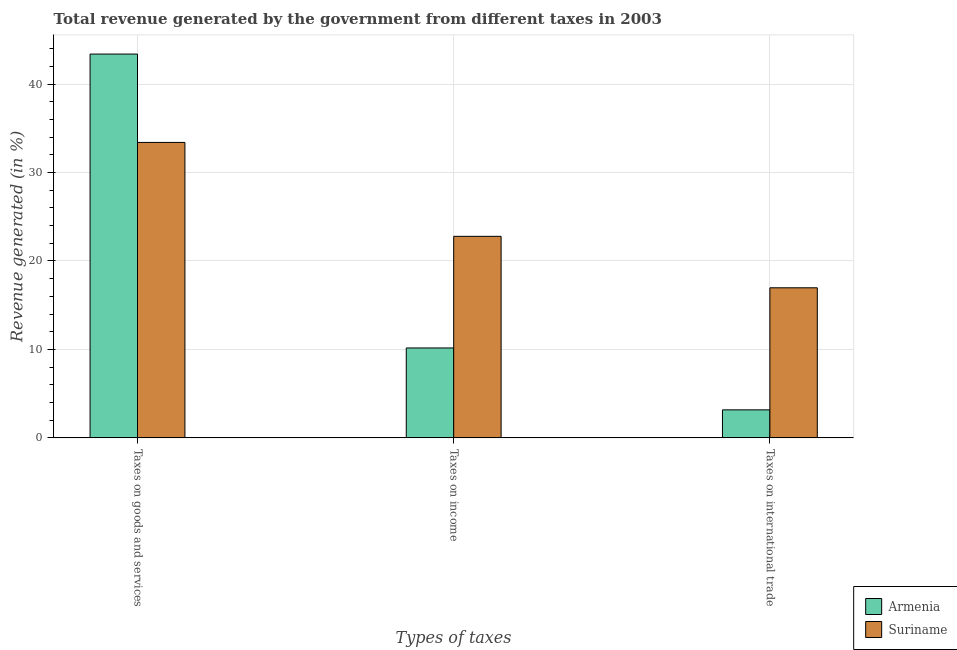How many different coloured bars are there?
Ensure brevity in your answer.  2. How many groups of bars are there?
Give a very brief answer. 3. Are the number of bars per tick equal to the number of legend labels?
Your answer should be very brief. Yes. What is the label of the 2nd group of bars from the left?
Your response must be concise. Taxes on income. What is the percentage of revenue generated by taxes on goods and services in Suriname?
Keep it short and to the point. 33.4. Across all countries, what is the maximum percentage of revenue generated by taxes on goods and services?
Provide a short and direct response. 43.39. Across all countries, what is the minimum percentage of revenue generated by taxes on goods and services?
Your answer should be very brief. 33.4. In which country was the percentage of revenue generated by taxes on goods and services maximum?
Give a very brief answer. Armenia. In which country was the percentage of revenue generated by tax on international trade minimum?
Provide a succinct answer. Armenia. What is the total percentage of revenue generated by tax on international trade in the graph?
Offer a very short reply. 20.14. What is the difference between the percentage of revenue generated by tax on international trade in Suriname and that in Armenia?
Keep it short and to the point. 13.8. What is the difference between the percentage of revenue generated by tax on international trade in Armenia and the percentage of revenue generated by taxes on goods and services in Suriname?
Give a very brief answer. -30.24. What is the average percentage of revenue generated by tax on international trade per country?
Ensure brevity in your answer.  10.07. What is the difference between the percentage of revenue generated by tax on international trade and percentage of revenue generated by taxes on income in Suriname?
Ensure brevity in your answer.  -5.82. In how many countries, is the percentage of revenue generated by taxes on income greater than 6 %?
Offer a very short reply. 2. What is the ratio of the percentage of revenue generated by taxes on income in Armenia to that in Suriname?
Your answer should be compact. 0.45. Is the difference between the percentage of revenue generated by taxes on goods and services in Suriname and Armenia greater than the difference between the percentage of revenue generated by taxes on income in Suriname and Armenia?
Your answer should be very brief. No. What is the difference between the highest and the second highest percentage of revenue generated by taxes on income?
Your answer should be very brief. 12.62. What is the difference between the highest and the lowest percentage of revenue generated by taxes on income?
Offer a terse response. 12.62. In how many countries, is the percentage of revenue generated by taxes on goods and services greater than the average percentage of revenue generated by taxes on goods and services taken over all countries?
Provide a short and direct response. 1. Is the sum of the percentage of revenue generated by tax on international trade in Armenia and Suriname greater than the maximum percentage of revenue generated by taxes on income across all countries?
Provide a short and direct response. No. What does the 1st bar from the left in Taxes on income represents?
Your answer should be compact. Armenia. What does the 1st bar from the right in Taxes on income represents?
Your response must be concise. Suriname. Is it the case that in every country, the sum of the percentage of revenue generated by taxes on goods and services and percentage of revenue generated by taxes on income is greater than the percentage of revenue generated by tax on international trade?
Keep it short and to the point. Yes. How many bars are there?
Give a very brief answer. 6. Are all the bars in the graph horizontal?
Offer a terse response. No. Where does the legend appear in the graph?
Make the answer very short. Bottom right. How many legend labels are there?
Your answer should be compact. 2. How are the legend labels stacked?
Provide a succinct answer. Vertical. What is the title of the graph?
Give a very brief answer. Total revenue generated by the government from different taxes in 2003. Does "Mexico" appear as one of the legend labels in the graph?
Your answer should be compact. No. What is the label or title of the X-axis?
Your answer should be compact. Types of taxes. What is the label or title of the Y-axis?
Make the answer very short. Revenue generated (in %). What is the Revenue generated (in %) in Armenia in Taxes on goods and services?
Make the answer very short. 43.39. What is the Revenue generated (in %) in Suriname in Taxes on goods and services?
Keep it short and to the point. 33.4. What is the Revenue generated (in %) of Armenia in Taxes on income?
Your answer should be compact. 10.17. What is the Revenue generated (in %) in Suriname in Taxes on income?
Give a very brief answer. 22.79. What is the Revenue generated (in %) of Armenia in Taxes on international trade?
Your answer should be very brief. 3.17. What is the Revenue generated (in %) of Suriname in Taxes on international trade?
Your answer should be compact. 16.97. Across all Types of taxes, what is the maximum Revenue generated (in %) in Armenia?
Your response must be concise. 43.39. Across all Types of taxes, what is the maximum Revenue generated (in %) of Suriname?
Your response must be concise. 33.4. Across all Types of taxes, what is the minimum Revenue generated (in %) of Armenia?
Provide a short and direct response. 3.17. Across all Types of taxes, what is the minimum Revenue generated (in %) in Suriname?
Offer a terse response. 16.97. What is the total Revenue generated (in %) of Armenia in the graph?
Make the answer very short. 56.73. What is the total Revenue generated (in %) in Suriname in the graph?
Offer a terse response. 73.16. What is the difference between the Revenue generated (in %) in Armenia in Taxes on goods and services and that in Taxes on income?
Provide a succinct answer. 33.23. What is the difference between the Revenue generated (in %) of Suriname in Taxes on goods and services and that in Taxes on income?
Provide a succinct answer. 10.62. What is the difference between the Revenue generated (in %) in Armenia in Taxes on goods and services and that in Taxes on international trade?
Provide a succinct answer. 40.23. What is the difference between the Revenue generated (in %) in Suriname in Taxes on goods and services and that in Taxes on international trade?
Your answer should be compact. 16.44. What is the difference between the Revenue generated (in %) of Armenia in Taxes on income and that in Taxes on international trade?
Keep it short and to the point. 7. What is the difference between the Revenue generated (in %) in Suriname in Taxes on income and that in Taxes on international trade?
Your response must be concise. 5.82. What is the difference between the Revenue generated (in %) in Armenia in Taxes on goods and services and the Revenue generated (in %) in Suriname in Taxes on income?
Give a very brief answer. 20.61. What is the difference between the Revenue generated (in %) of Armenia in Taxes on goods and services and the Revenue generated (in %) of Suriname in Taxes on international trade?
Provide a short and direct response. 26.43. What is the difference between the Revenue generated (in %) in Armenia in Taxes on income and the Revenue generated (in %) in Suriname in Taxes on international trade?
Give a very brief answer. -6.8. What is the average Revenue generated (in %) of Armenia per Types of taxes?
Keep it short and to the point. 18.91. What is the average Revenue generated (in %) of Suriname per Types of taxes?
Give a very brief answer. 24.39. What is the difference between the Revenue generated (in %) in Armenia and Revenue generated (in %) in Suriname in Taxes on goods and services?
Keep it short and to the point. 9.99. What is the difference between the Revenue generated (in %) of Armenia and Revenue generated (in %) of Suriname in Taxes on income?
Your answer should be very brief. -12.62. What is the difference between the Revenue generated (in %) in Armenia and Revenue generated (in %) in Suriname in Taxes on international trade?
Offer a terse response. -13.8. What is the ratio of the Revenue generated (in %) of Armenia in Taxes on goods and services to that in Taxes on income?
Offer a terse response. 4.27. What is the ratio of the Revenue generated (in %) in Suriname in Taxes on goods and services to that in Taxes on income?
Your response must be concise. 1.47. What is the ratio of the Revenue generated (in %) in Armenia in Taxes on goods and services to that in Taxes on international trade?
Keep it short and to the point. 13.7. What is the ratio of the Revenue generated (in %) of Suriname in Taxes on goods and services to that in Taxes on international trade?
Make the answer very short. 1.97. What is the ratio of the Revenue generated (in %) in Armenia in Taxes on income to that in Taxes on international trade?
Your response must be concise. 3.21. What is the ratio of the Revenue generated (in %) of Suriname in Taxes on income to that in Taxes on international trade?
Your answer should be compact. 1.34. What is the difference between the highest and the second highest Revenue generated (in %) in Armenia?
Offer a terse response. 33.23. What is the difference between the highest and the second highest Revenue generated (in %) of Suriname?
Your answer should be compact. 10.62. What is the difference between the highest and the lowest Revenue generated (in %) of Armenia?
Your answer should be very brief. 40.23. What is the difference between the highest and the lowest Revenue generated (in %) of Suriname?
Provide a short and direct response. 16.44. 